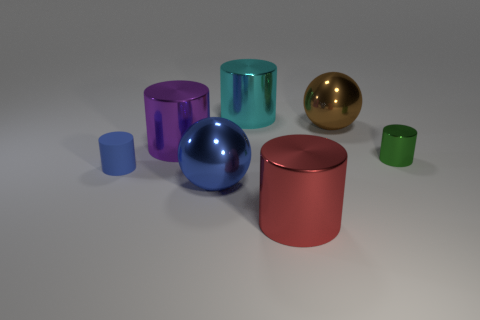What could be the purpose of this arrangement? Is it for an advertisement, an art piece, or something else? The arrangement of these objects seems purposeful and could very well serve as a representation for a 3D modeling and rendering showcase. It could possibly be used for advertising to demonstrate the capabilities of a graphic design software or for an art piece emphasizing form and color composition. The clean and minimalist setup suggests a focus on the objects' geometric shapes and the interplay of light and shadow. 